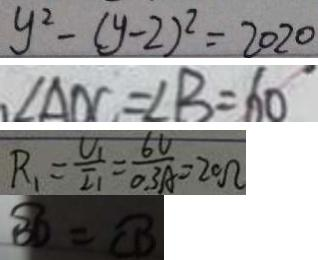<formula> <loc_0><loc_0><loc_500><loc_500>y ^ { 2 } - ( y - 2 ) ^ { 2 } = 2 0 2 0 
 \angle A D C = \angle B = 6 0 
 R _ { 1 } = \frac { U _ { 1 } } { I _ { 1 } } = \frac { 6 V } { 0 . 3 A } = 2 0 \Omega 
 \widehat { B D } = \widehat { C D }</formula> 